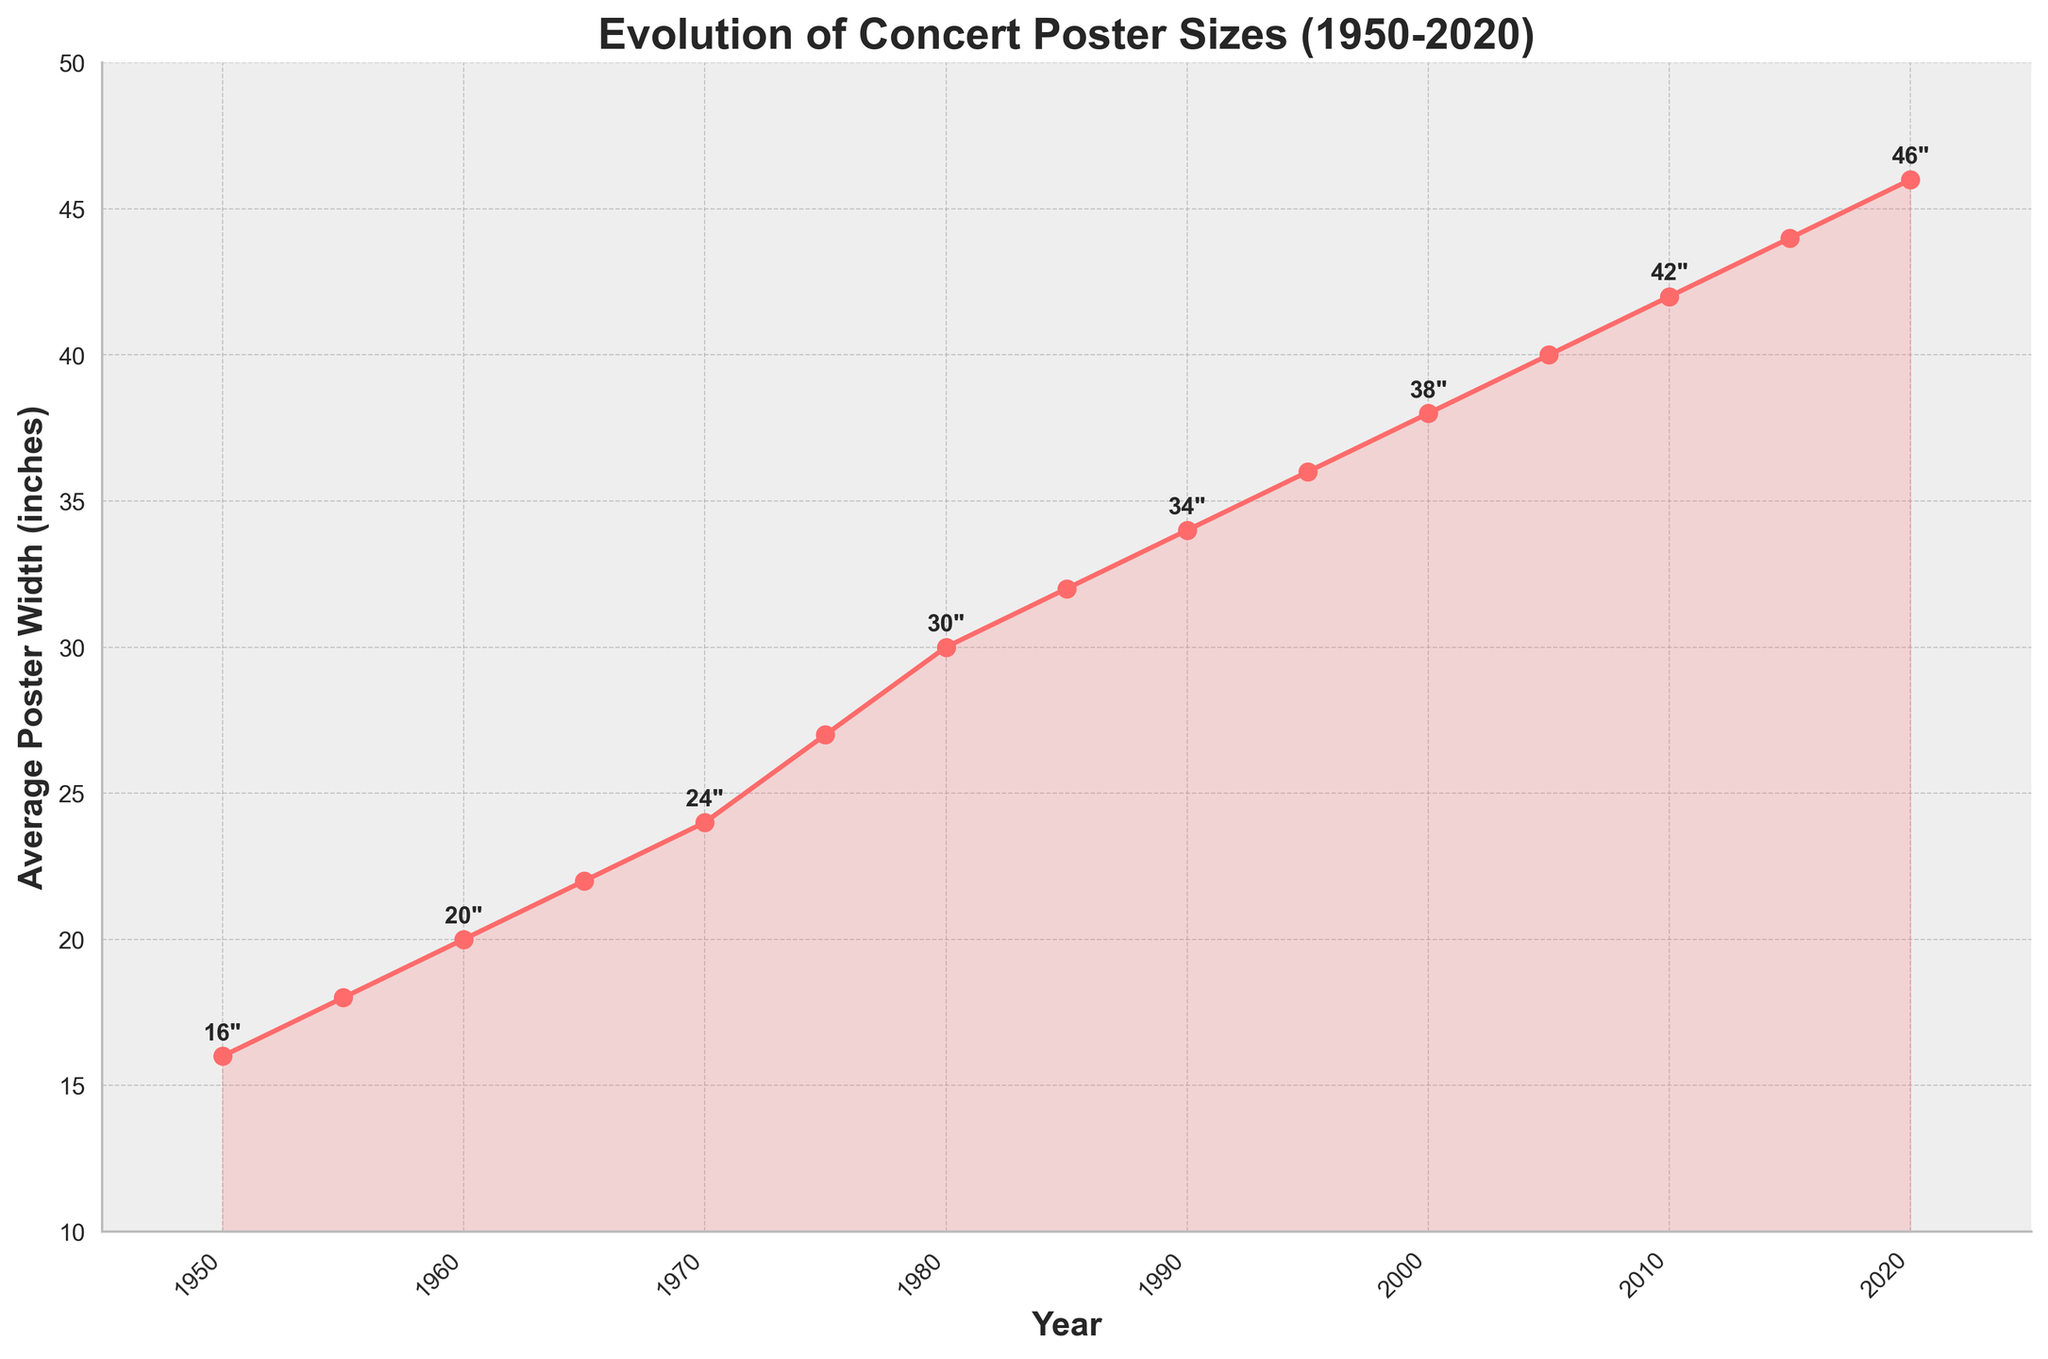What's the size of the concert posters in 1960? The figure shows that in 1960, the concert posters had an average size of 20x28 inches.
Answer: 20x28 inches How did the size of posters change between 1970 and 1980? In 1970, the size was 24x36 inches and in 1980, it was 30x40 inches. Therefore, the width increased by 6 inches (30 - 24).
Answer: Increased by 6 inches Which decade saw the greatest increase in poster size? To find this, calculate the differences for each decade:
1950-1960: 20 - 16 = 4 inches,
1960-1970: 24 - 20 = 4 inches,
1970-1980: 30 - 24 = 6 inches,
1980-1990: 34 - 30 = 4 inches,
1990-2000: 38 - 34 = 4 inches,
2000-2010: 42 - 38 = 4 inches,
2010-2020: 46 - 42 = 4 inches.
The decade with the greatest increase was 1970-1980.
Answer: 1970-1980 At what year did the poster size reach 30x40 inches? By observing the plot, we can see that the size of the posters was 30x40 inches in the year 1980.
Answer: 1980 What trend can be observed in the evolution of concert poster sizes from 1950 to 2020? The plot shows a consistent increasing trend in the average poster size every decade from 1950 to 2020.
Answer: Increasing trend Between which two years was the smallest increase in poster sizes observed? Calculate the differences year by year:
1950-1955: 18 - 16 = 2 inches,
1955-1960: 20 - 18 = 2 inches,
1960-1965: 22 - 20 = 2 inches,
1965-1970: 24 - 22 = 2 inches,
1970-1975: 27 - 24 = 3 inches,
1975-1980: 30 - 27 = 3 inches,
1980-1985: 32 - 30 = 2 inches,
1985-1990: 34 - 32 = 2 inches,
1990-1995: 36 - 34 = 2 inches,
1995-2000: 38 - 36 = 2 inches,
2000-2005: 40 - 38 = 2 inches,
2005-2010: 42 - 40 = 2 inches,
2010-2015: 44 - 42 = 2 inches,
2015-2020: 46 - 44 = 2 inches.
The smallest increase is 2 inches, observed between multiple years.
Answer: Multiple years with 2-inch increase What is the average width of concert posters from 1950 to 2020? The average width is calculated as follows: (16 + 18 + 20 + 22 + 24 + 27 + 30 + 32 + 34 + 36 + 38 + 40 + 42 + 44 + 46) / 15 = 498 / 15 = 33.2 inches.
Answer: 33.2 inches How many years had poster sizes exactly divisible by 4? Checking the widths: 16, 18, 20, 22, 24, 27, 30, 32, 34, 36, 38, 40, 42, 44, 46:
16, 20, 24, 32, 36, 40, 44 are exactly divisible by 4. Therefore, there are 7 years in total.
Answer: 7 years 